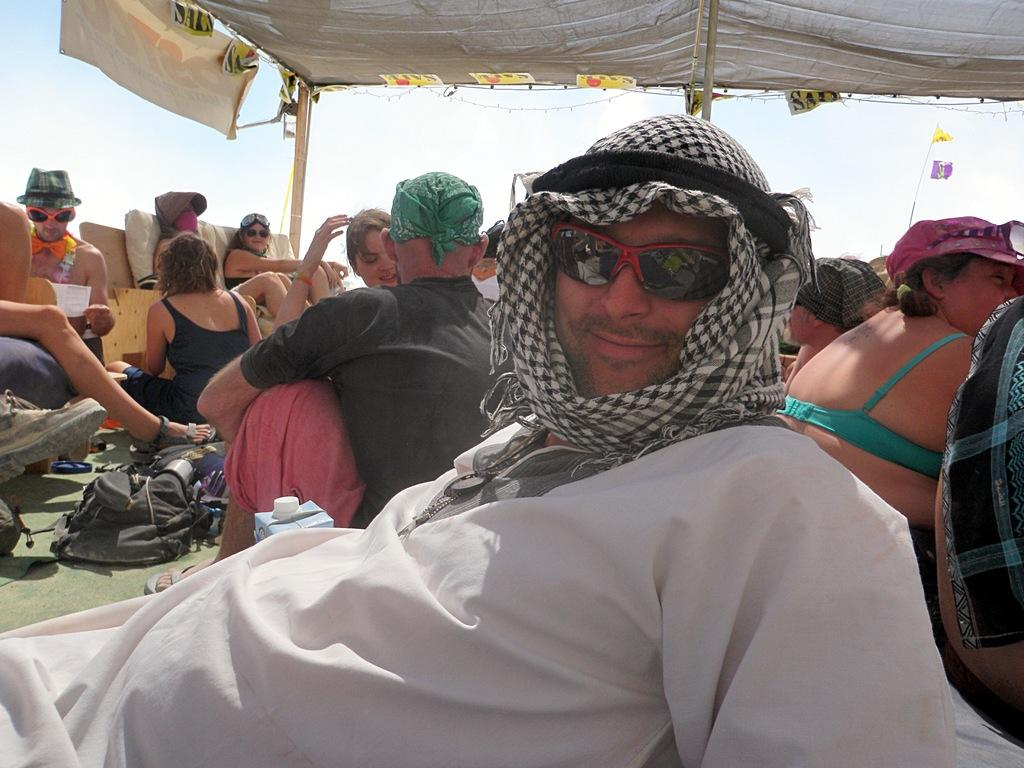How many people are in the image? There is a group of persons in the image, but the exact number is not specified. Where are the persons located in the image? The group of persons is under a tent. What is visible at the top of the image? The sky is visible at the top of the image. What type of locket is hanging from the tent in the image? There is no locket present in the image; it only features a group of persons under a tent. Can you tell me how many pickles are on the table in the image? There is no table or pickles present in the image. 